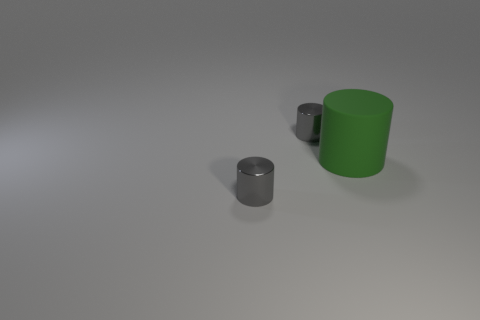Are there any other things that have the same size as the green cylinder?
Your response must be concise. No. Is there any other thing that is made of the same material as the green thing?
Your answer should be compact. No. There is a tiny thing that is behind the big green cylinder; does it have the same color as the tiny metal cylinder in front of the big matte cylinder?
Your response must be concise. Yes. What number of other things are there of the same shape as the green matte object?
Offer a very short reply. 2. Is there a big blue cylinder?
Offer a very short reply. No. How many things are rubber cylinders or tiny gray cylinders in front of the big matte object?
Your answer should be compact. 2. There is a gray thing in front of the matte cylinder; does it have the same size as the big green matte thing?
Give a very brief answer. No. What number of other things are there of the same size as the green rubber cylinder?
Your answer should be very brief. 0. The matte object is what color?
Provide a succinct answer. Green. Are there the same number of large green matte things on the left side of the large rubber cylinder and small yellow matte objects?
Offer a very short reply. Yes. 